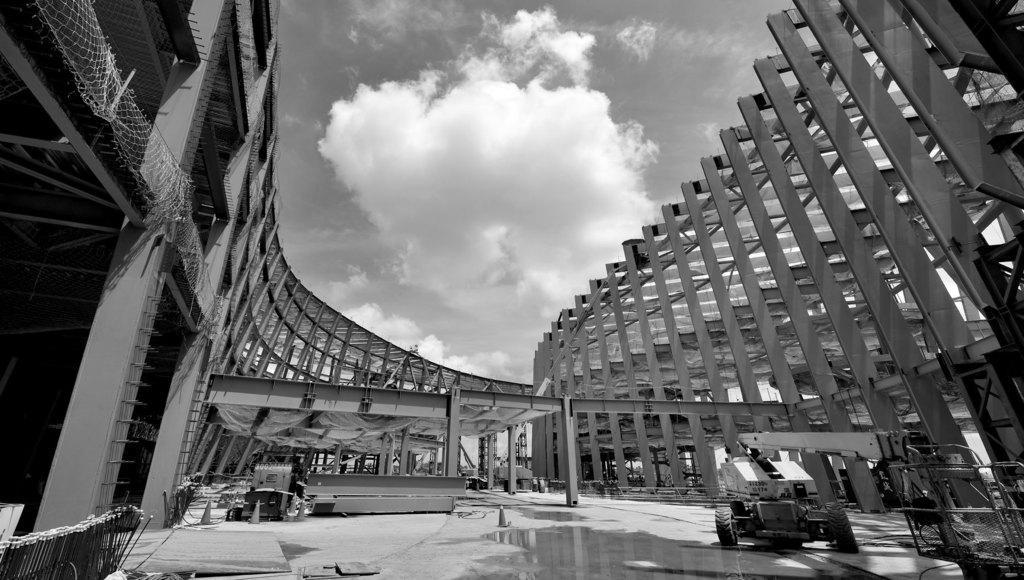Please provide a concise description of this image. In the picture we can see the pole construction around the surface and we can see the construction equipment, vehicle and to the top we can see the sky with clouds. 